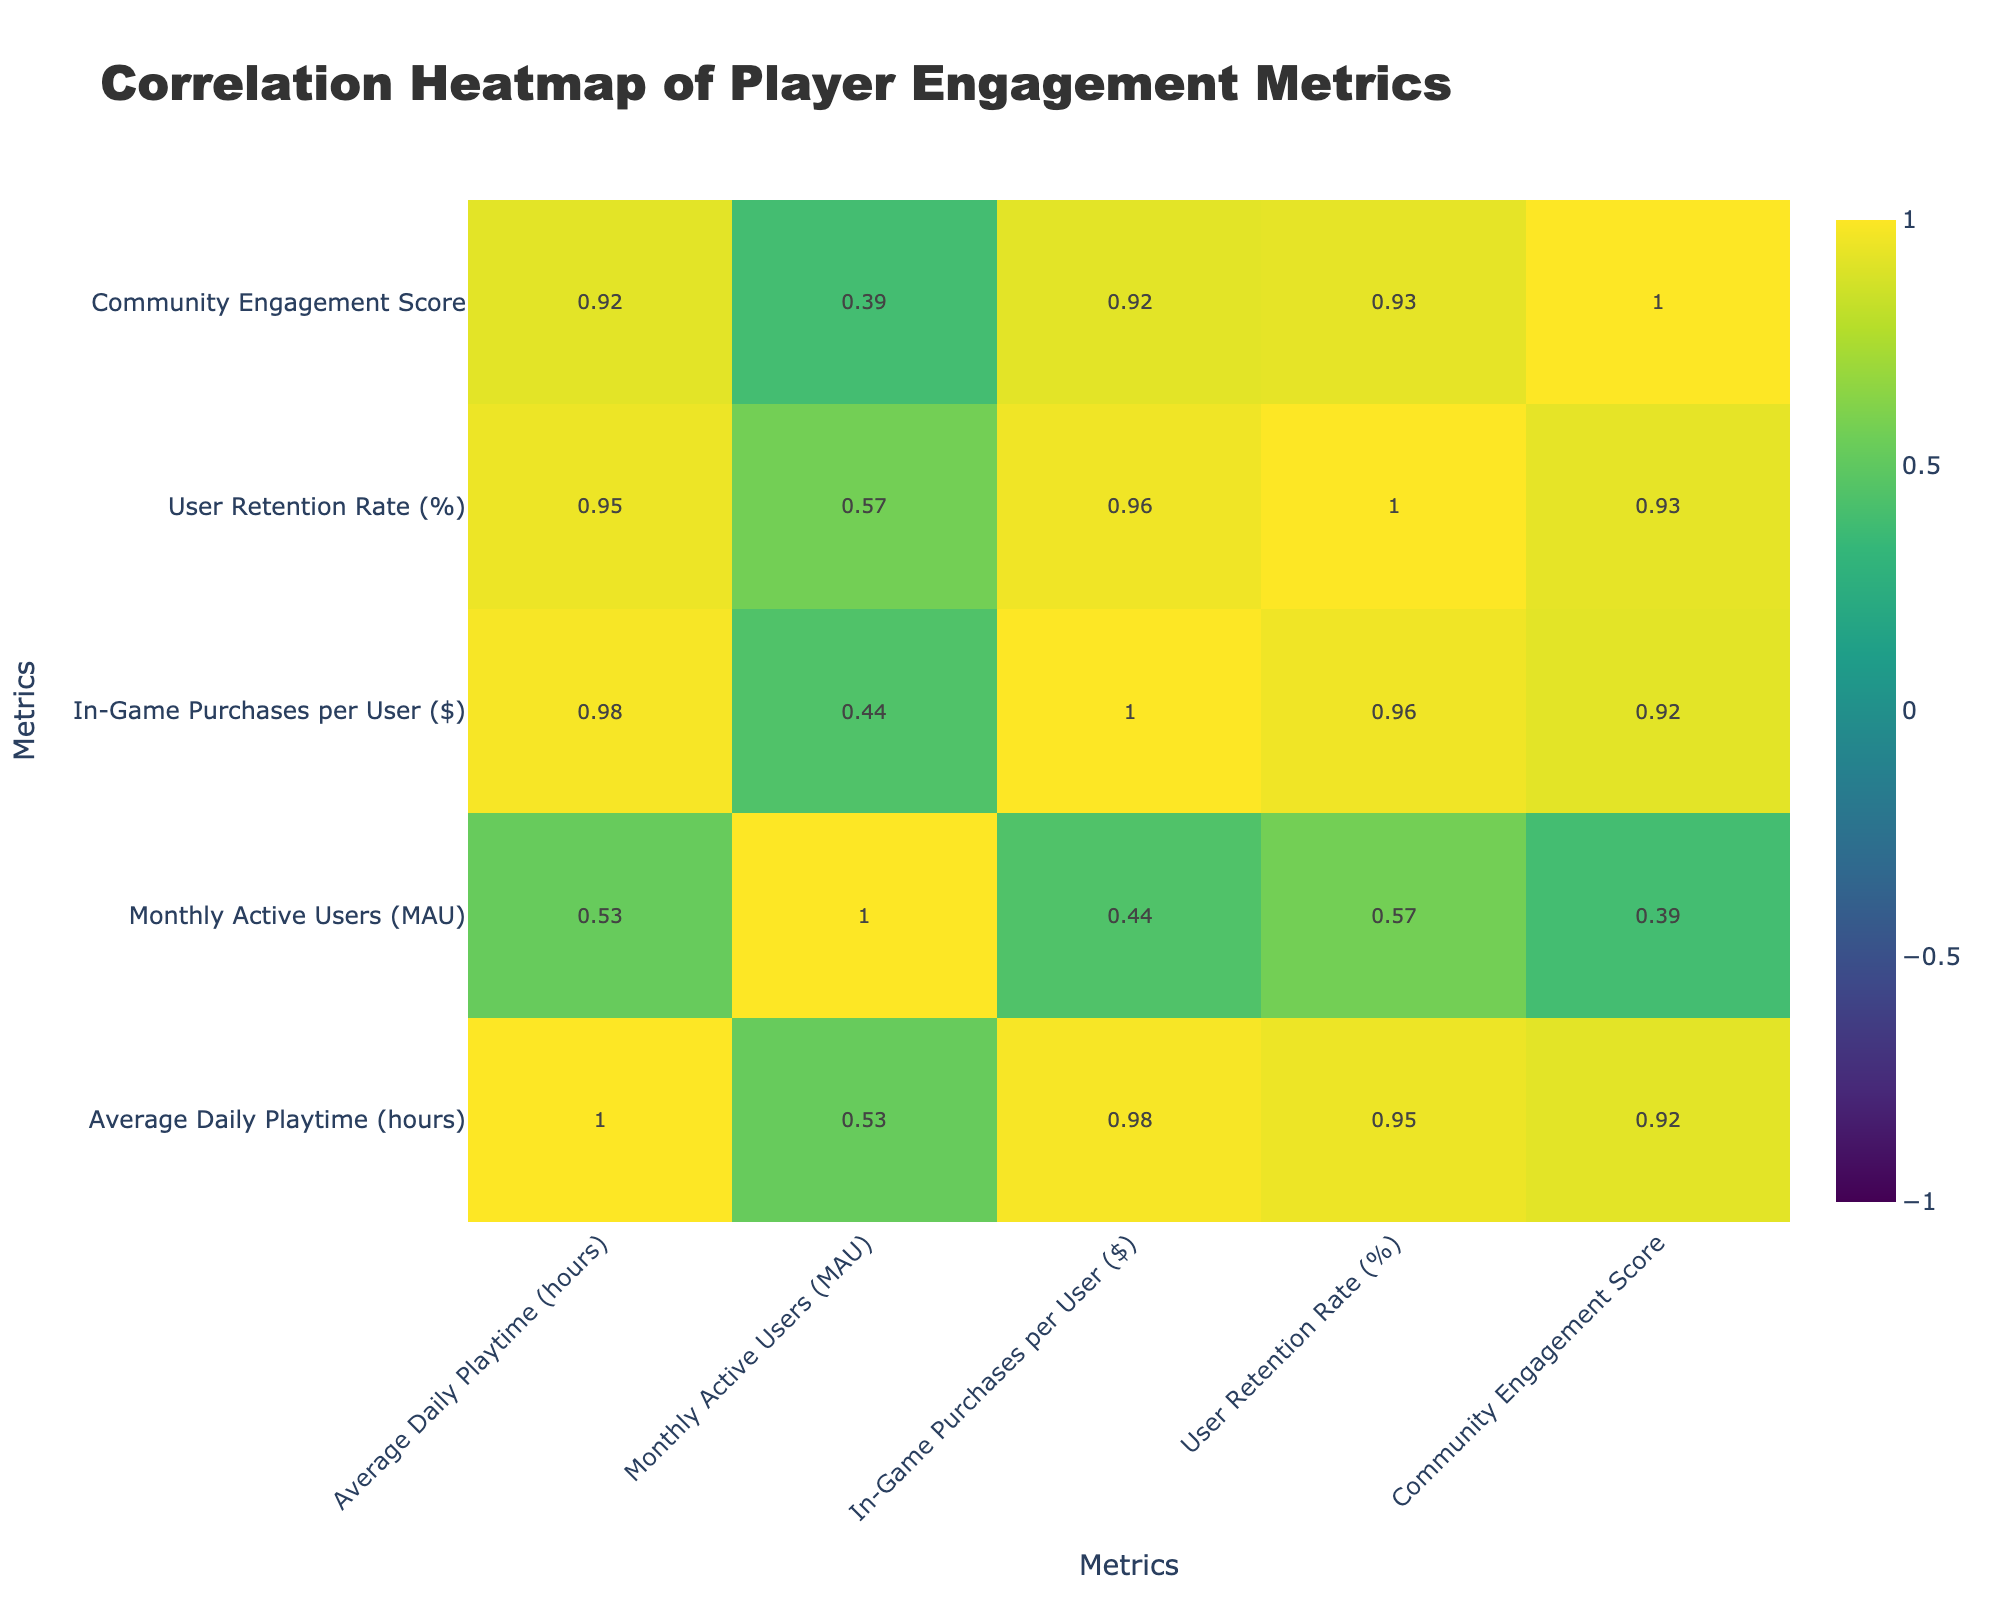What is the Average Daily Playtime for RPG games? The value of Average Daily Playtime for RPG games is directly found in the table under the respective row. It shows that RPG games have an Average Daily Playtime of 4.2 hours.
Answer: 4.2 Which game genre has the highest User Retention Rate? To find this, we compare the User Retention Rate values across all game genres. The highest value is found in the MMORPG genre, which is 72%.
Answer: 72% Is there a positive correlation between Monthly Active Users and In-Game Purchases per User? The correlation coefficient between Monthly Active Users and In-Game Purchases per User is determined from the table's correlation matrix. If it shows a positive value, it confirms there is a positive correlation. Yes, a positive correlation exists.
Answer: Yes What is the difference in Average Daily Playtime between Sports and Simulation genres? To find the difference, we take the Average Daily Playtime for Sports (3.8 hours) and Simulation (2.9 hours) and calculate 3.8 - 2.9 = 0.9 hours.
Answer: 0.9 Which game genre has the lowest Community Engagement Score and what is that score? The Community Engagement Score is compared across all genres. The lowest score occurs in the MOBA genre, which is 55.
Answer: 55 If we average the In-Game Purchases per User for all genres, what is that average? To calculate the average, we sum up all the In-Game Purchases per User values and divide by the number of genres (10). The total is (18.50 + 15.25 + 22.75 + 17.00 + 10.50 + 12.30 + 25.00 + 5.00 + 8.25 + 30.00) =  139.55; then 139.55 / 10 = 13.955.
Answer: 13.96 Do Adventure games have a higher Average Daily Playtime than FPS games? We look at the Average Daily Playtime for both genres: Adventure (2.8 hours) and FPS (3.1 hours). Since 2.8 is less than 3.1, Adventure games do not have a higher playtime.
Answer: No What is the sum of Monthly Active Users for Action and RPG genres? To find the sum, we take the Monthly Active Users for Action (1,500,000) and RPG (2,500,000) and calculate 1,500,000 + 2,500,000 = 4,000,000.
Answer: 4,000,000 Does the Simulation genre have a higher In-Game Purchases per User than the Puzzle genre? We need to check the In-Game Purchases per User for both genres: Simulation (12.30) and Puzzle (5.00). Since 12.30 is greater than 5.00, the statement is true.
Answer: Yes 